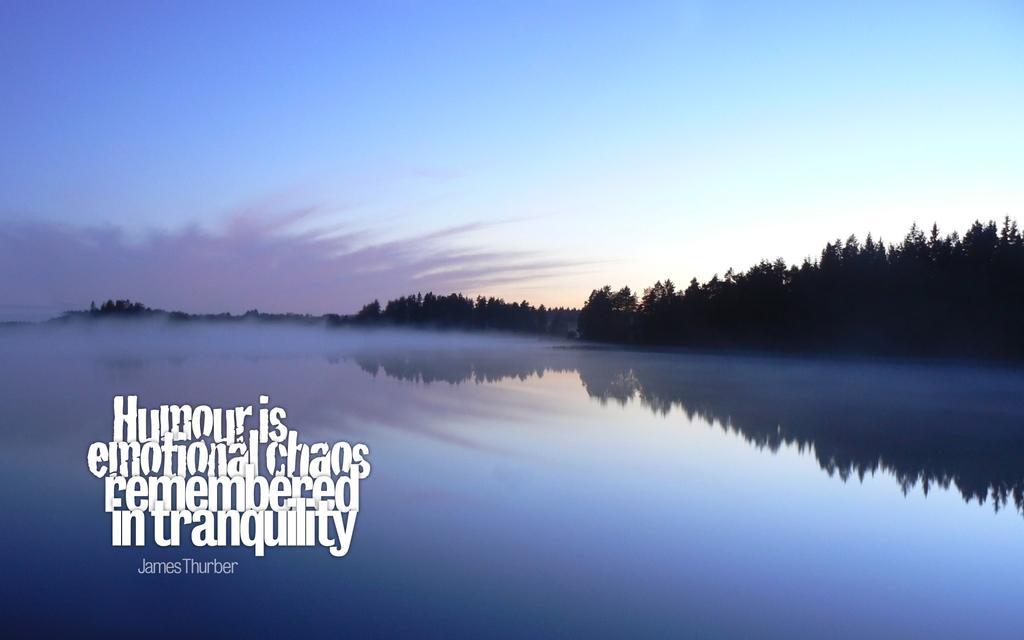How would you summarize this image in a sentence or two? In the foreground of the picture there are text, water body and smoke. In the background there are trees. At the top it is sky. 